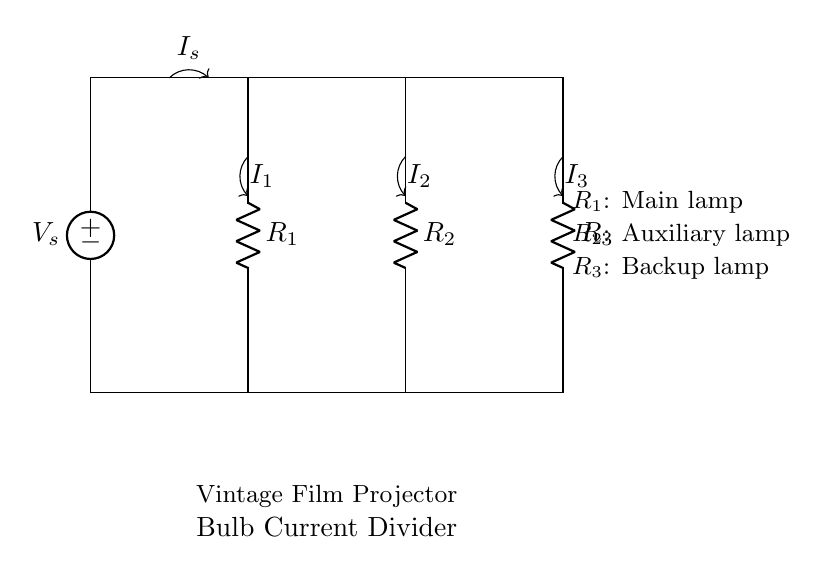What is the total current entering the circuit? The total current entering the circuit is represented by the source current, labeled as I_s, and it is the sum of the currents through all resistors in the parallel arrangement.
Answer: I_s How many resistors are in the circuit? The circuit diagram clearly shows three resistors: R_1, R_2, and R_3. Each of these resistors corresponds to a different lamp in the vintage film projector system.
Answer: 3 Which resistor corresponds to the main lamp? The resistor labeled R_1 corresponds to the main lamp in the circuit, as indicated by the description next to it.
Answer: R_1 What can be determined about the currents flowing through each resistor? The currents I_1, I_2, and I_3 through each resistor are inversely proportional to their resistance values according to the current divider rule. Therefore, the largest current flows through the smallest resistor.
Answer: Proportional to resistance If R_1 has the lowest resistance, which lamp will receive the most current? Since R_1 has the lowest resistance, it will have the highest current flowing through it compared to the other resistors in parallel. Therefore, the main lamp will receive the most current in the circuit.
Answer: Main lamp What is the purpose of the auxiliary lamp represented by R_2? The auxiliary lamp, represented by R_2, serves as a secondary source of illumination when the main lamp is inadequate or fails, ensuring continuous operation of the projector.
Answer: Backup illumination 